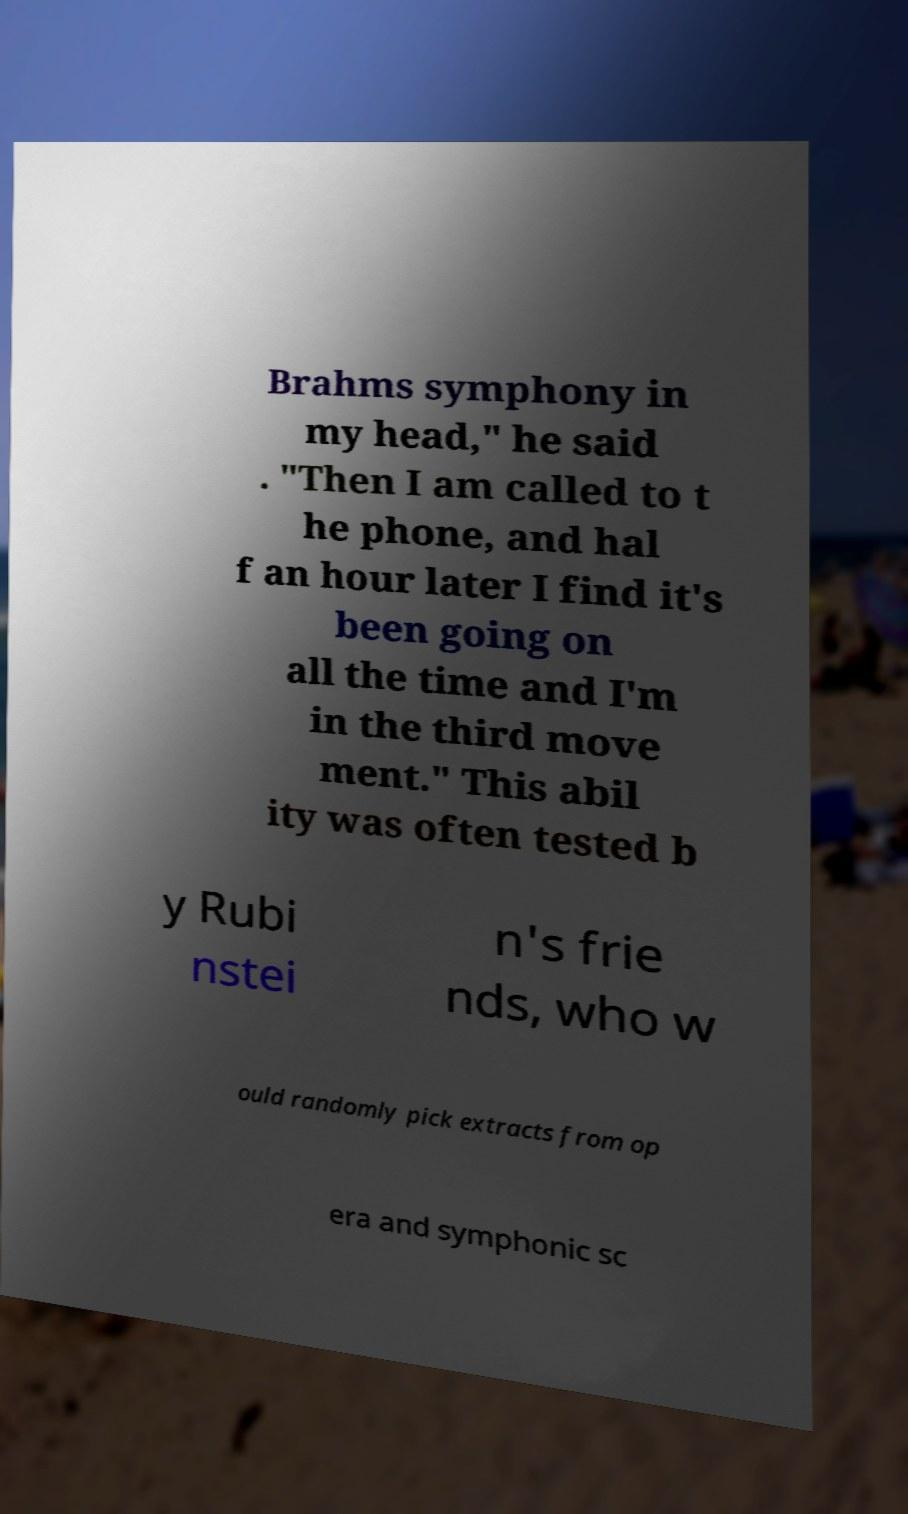Can you accurately transcribe the text from the provided image for me? Brahms symphony in my head," he said . "Then I am called to t he phone, and hal f an hour later I find it's been going on all the time and I'm in the third move ment." This abil ity was often tested b y Rubi nstei n's frie nds, who w ould randomly pick extracts from op era and symphonic sc 